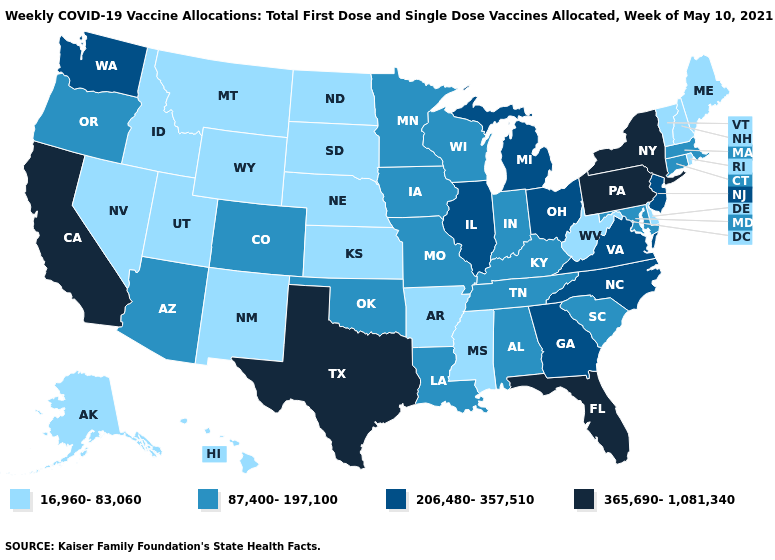Does New Hampshire have the lowest value in the Northeast?
Short answer required. Yes. Name the states that have a value in the range 87,400-197,100?
Write a very short answer. Alabama, Arizona, Colorado, Connecticut, Indiana, Iowa, Kentucky, Louisiana, Maryland, Massachusetts, Minnesota, Missouri, Oklahoma, Oregon, South Carolina, Tennessee, Wisconsin. Name the states that have a value in the range 16,960-83,060?
Write a very short answer. Alaska, Arkansas, Delaware, Hawaii, Idaho, Kansas, Maine, Mississippi, Montana, Nebraska, Nevada, New Hampshire, New Mexico, North Dakota, Rhode Island, South Dakota, Utah, Vermont, West Virginia, Wyoming. What is the value of New York?
Short answer required. 365,690-1,081,340. What is the value of New Jersey?
Write a very short answer. 206,480-357,510. Does Idaho have the lowest value in the USA?
Write a very short answer. Yes. What is the lowest value in the USA?
Give a very brief answer. 16,960-83,060. Name the states that have a value in the range 16,960-83,060?
Give a very brief answer. Alaska, Arkansas, Delaware, Hawaii, Idaho, Kansas, Maine, Mississippi, Montana, Nebraska, Nevada, New Hampshire, New Mexico, North Dakota, Rhode Island, South Dakota, Utah, Vermont, West Virginia, Wyoming. Among the states that border Oregon , does Idaho have the highest value?
Concise answer only. No. Among the states that border Indiana , which have the highest value?
Answer briefly. Illinois, Michigan, Ohio. Does Montana have a lower value than Oklahoma?
Quick response, please. Yes. Does Idaho have the lowest value in the USA?
Be succinct. Yes. What is the lowest value in the MidWest?
Write a very short answer. 16,960-83,060. Does Vermont have the highest value in the USA?
Give a very brief answer. No. Does the first symbol in the legend represent the smallest category?
Be succinct. Yes. 